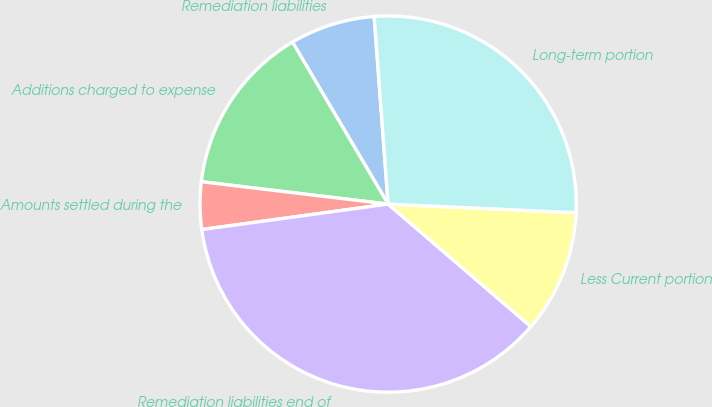<chart> <loc_0><loc_0><loc_500><loc_500><pie_chart><fcel>Remediation liabilities<fcel>Additions charged to expense<fcel>Amounts settled during the<fcel>Remediation liabilities end of<fcel>Less Current portion<fcel>Long-term portion<nl><fcel>7.31%<fcel>14.61%<fcel>4.06%<fcel>36.55%<fcel>10.56%<fcel>26.91%<nl></chart> 